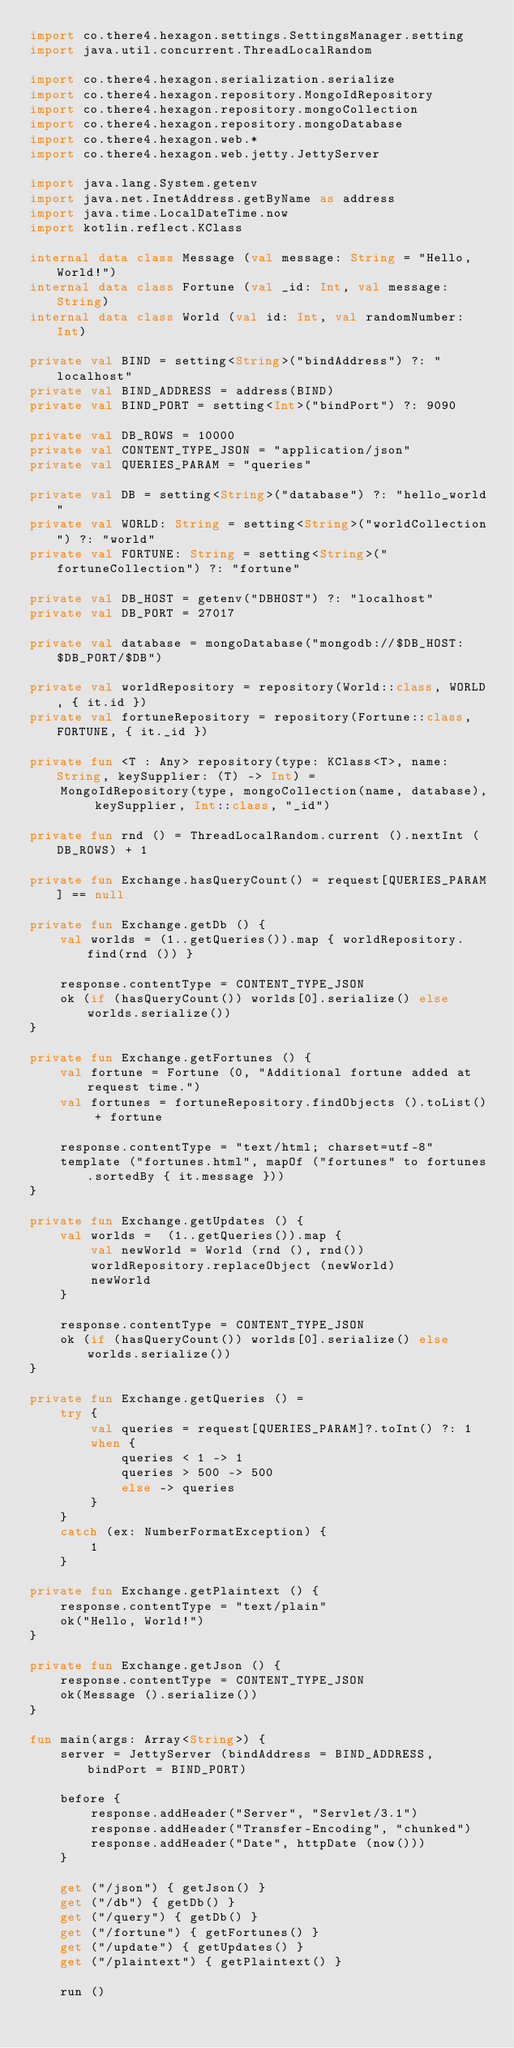Convert code to text. <code><loc_0><loc_0><loc_500><loc_500><_Kotlin_>import co.there4.hexagon.settings.SettingsManager.setting
import java.util.concurrent.ThreadLocalRandom

import co.there4.hexagon.serialization.serialize
import co.there4.hexagon.repository.MongoIdRepository
import co.there4.hexagon.repository.mongoCollection
import co.there4.hexagon.repository.mongoDatabase
import co.there4.hexagon.web.*
import co.there4.hexagon.web.jetty.JettyServer

import java.lang.System.getenv
import java.net.InetAddress.getByName as address
import java.time.LocalDateTime.now
import kotlin.reflect.KClass

internal data class Message (val message: String = "Hello, World!")
internal data class Fortune (val _id: Int, val message: String)
internal data class World (val id: Int, val randomNumber: Int)

private val BIND = setting<String>("bindAddress") ?: "localhost"
private val BIND_ADDRESS = address(BIND)
private val BIND_PORT = setting<Int>("bindPort") ?: 9090

private val DB_ROWS = 10000
private val CONTENT_TYPE_JSON = "application/json"
private val QUERIES_PARAM = "queries"

private val DB = setting<String>("database") ?: "hello_world"
private val WORLD: String = setting<String>("worldCollection") ?: "world"
private val FORTUNE: String = setting<String>("fortuneCollection") ?: "fortune"

private val DB_HOST = getenv("DBHOST") ?: "localhost"
private val DB_PORT = 27017

private val database = mongoDatabase("mongodb://$DB_HOST:$DB_PORT/$DB")

private val worldRepository = repository(World::class, WORLD, { it.id })
private val fortuneRepository = repository(Fortune::class, FORTUNE, { it._id })

private fun <T : Any> repository(type: KClass<T>, name: String, keySupplier: (T) -> Int) =
    MongoIdRepository(type, mongoCollection(name, database), keySupplier, Int::class, "_id")

private fun rnd () = ThreadLocalRandom.current ().nextInt (DB_ROWS) + 1

private fun Exchange.hasQueryCount() = request[QUERIES_PARAM] == null

private fun Exchange.getDb () {
    val worlds = (1..getQueries()).map { worldRepository.find(rnd ()) }

    response.contentType = CONTENT_TYPE_JSON
    ok (if (hasQueryCount()) worlds[0].serialize() else worlds.serialize())
}

private fun Exchange.getFortunes () {
    val fortune = Fortune (0, "Additional fortune added at request time.")
    val fortunes = fortuneRepository.findObjects ().toList() + fortune

    response.contentType = "text/html; charset=utf-8"
    template ("fortunes.html", mapOf ("fortunes" to fortunes.sortedBy { it.message }))
}

private fun Exchange.getUpdates () {
    val worlds =  (1..getQueries()).map {
        val newWorld = World (rnd (), rnd())
        worldRepository.replaceObject (newWorld)
        newWorld
    }

    response.contentType = CONTENT_TYPE_JSON
    ok (if (hasQueryCount()) worlds[0].serialize() else worlds.serialize())
}

private fun Exchange.getQueries () =
    try {
        val queries = request[QUERIES_PARAM]?.toInt() ?: 1
        when {
            queries < 1 -> 1
            queries > 500 -> 500
            else -> queries
        }
    }
    catch (ex: NumberFormatException) {
        1
    }

private fun Exchange.getPlaintext () {
    response.contentType = "text/plain"
    ok("Hello, World!")
}

private fun Exchange.getJson () {
    response.contentType = CONTENT_TYPE_JSON
    ok(Message ().serialize())
}

fun main(args: Array<String>) {
    server = JettyServer (bindAddress = BIND_ADDRESS, bindPort = BIND_PORT)

    before {
        response.addHeader("Server", "Servlet/3.1")
        response.addHeader("Transfer-Encoding", "chunked")
        response.addHeader("Date", httpDate (now()))
    }

    get ("/json") { getJson() }
    get ("/db") { getDb() }
    get ("/query") { getDb() }
    get ("/fortune") { getFortunes() }
    get ("/update") { getUpdates() }
    get ("/plaintext") { getPlaintext() }

    run ()</code> 